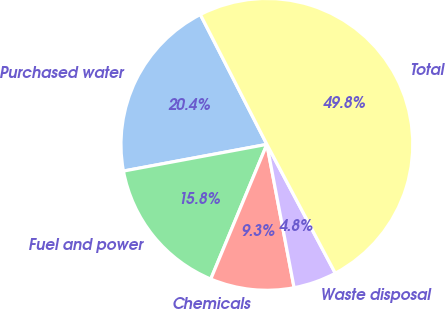<chart> <loc_0><loc_0><loc_500><loc_500><pie_chart><fcel>Purchased water<fcel>Fuel and power<fcel>Chemicals<fcel>Waste disposal<fcel>Total<nl><fcel>20.39%<fcel>15.79%<fcel>9.27%<fcel>4.78%<fcel>49.77%<nl></chart> 